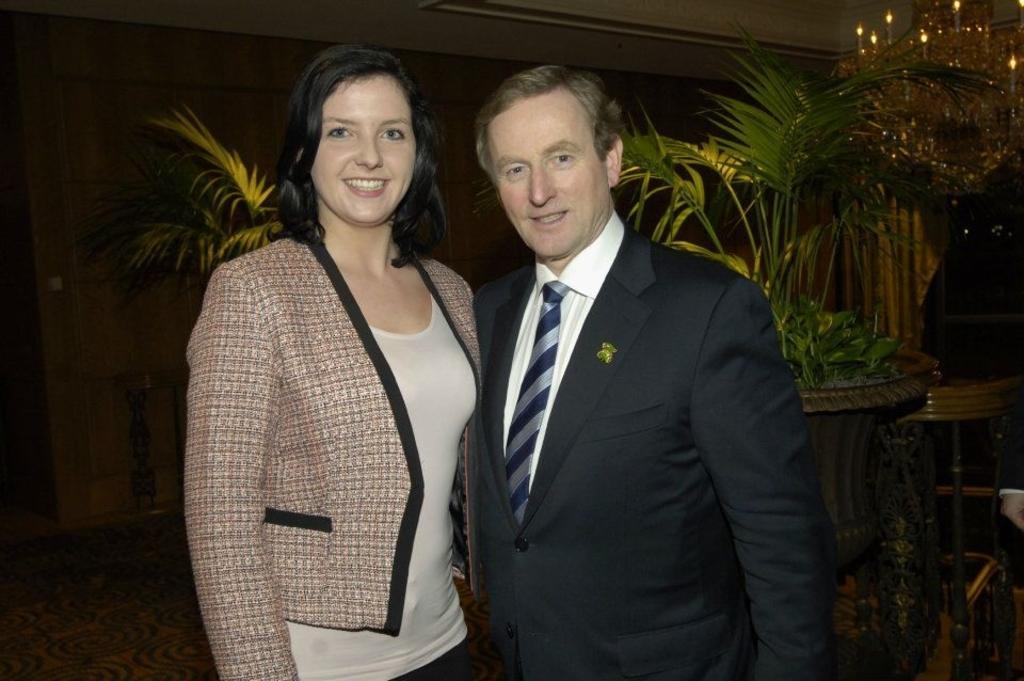Please provide a concise description of this image. On the left side, there is a woman in white color t-shirt, smiling and standing. Beside her, there is a person in a suit, smiling and standing. In the background, there are plants. And the background is dark in color. 